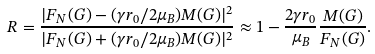Convert formula to latex. <formula><loc_0><loc_0><loc_500><loc_500>R = \frac { | F _ { N } ( G ) - ( \gamma r _ { 0 } / 2 \mu _ { B } ) { M } ( G ) | ^ { 2 } } { | F _ { N } ( G ) + ( \gamma r _ { 0 } / 2 \mu _ { B } ) { M } ( G ) | ^ { 2 } } \approx 1 - \frac { 2 \gamma r _ { 0 } } { \mu _ { B } } \frac { { M } ( G ) } { F _ { N } ( G ) } .</formula> 